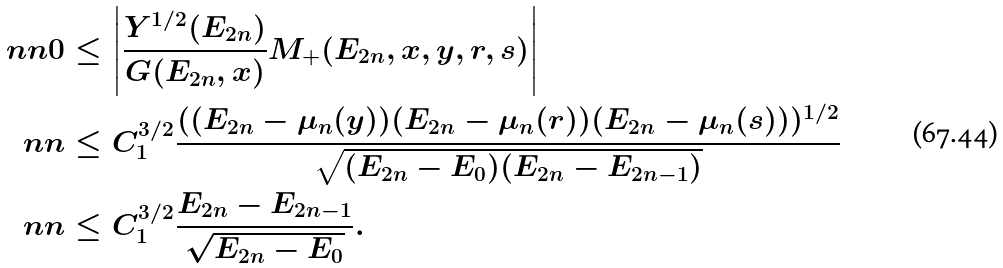Convert formula to latex. <formula><loc_0><loc_0><loc_500><loc_500>\ n n 0 & \leq \left | \frac { Y ^ { 1 / 2 } ( E _ { 2 n } ) } { G ( E _ { 2 n } , x ) } M _ { + } ( E _ { 2 n } , x , y , r , s ) \right | \\ \ n n & \leq C _ { 1 } ^ { 3 / 2 } \frac { ( ( E _ { 2 n } - \mu _ { n } ( y ) ) ( E _ { 2 n } - \mu _ { n } ( r ) ) ( E _ { 2 n } - \mu _ { n } ( s ) ) ) ^ { 1 / 2 } } { \sqrt { ( E _ { 2 n } - E _ { 0 } ) ( E _ { 2 n } - E _ { 2 n - 1 } ) } } \\ \ n n & \leq C _ { 1 } ^ { 3 / 2 } \frac { E _ { 2 n } - E _ { 2 n - 1 } } { \sqrt { E _ { 2 n } - E _ { 0 } } } .</formula> 